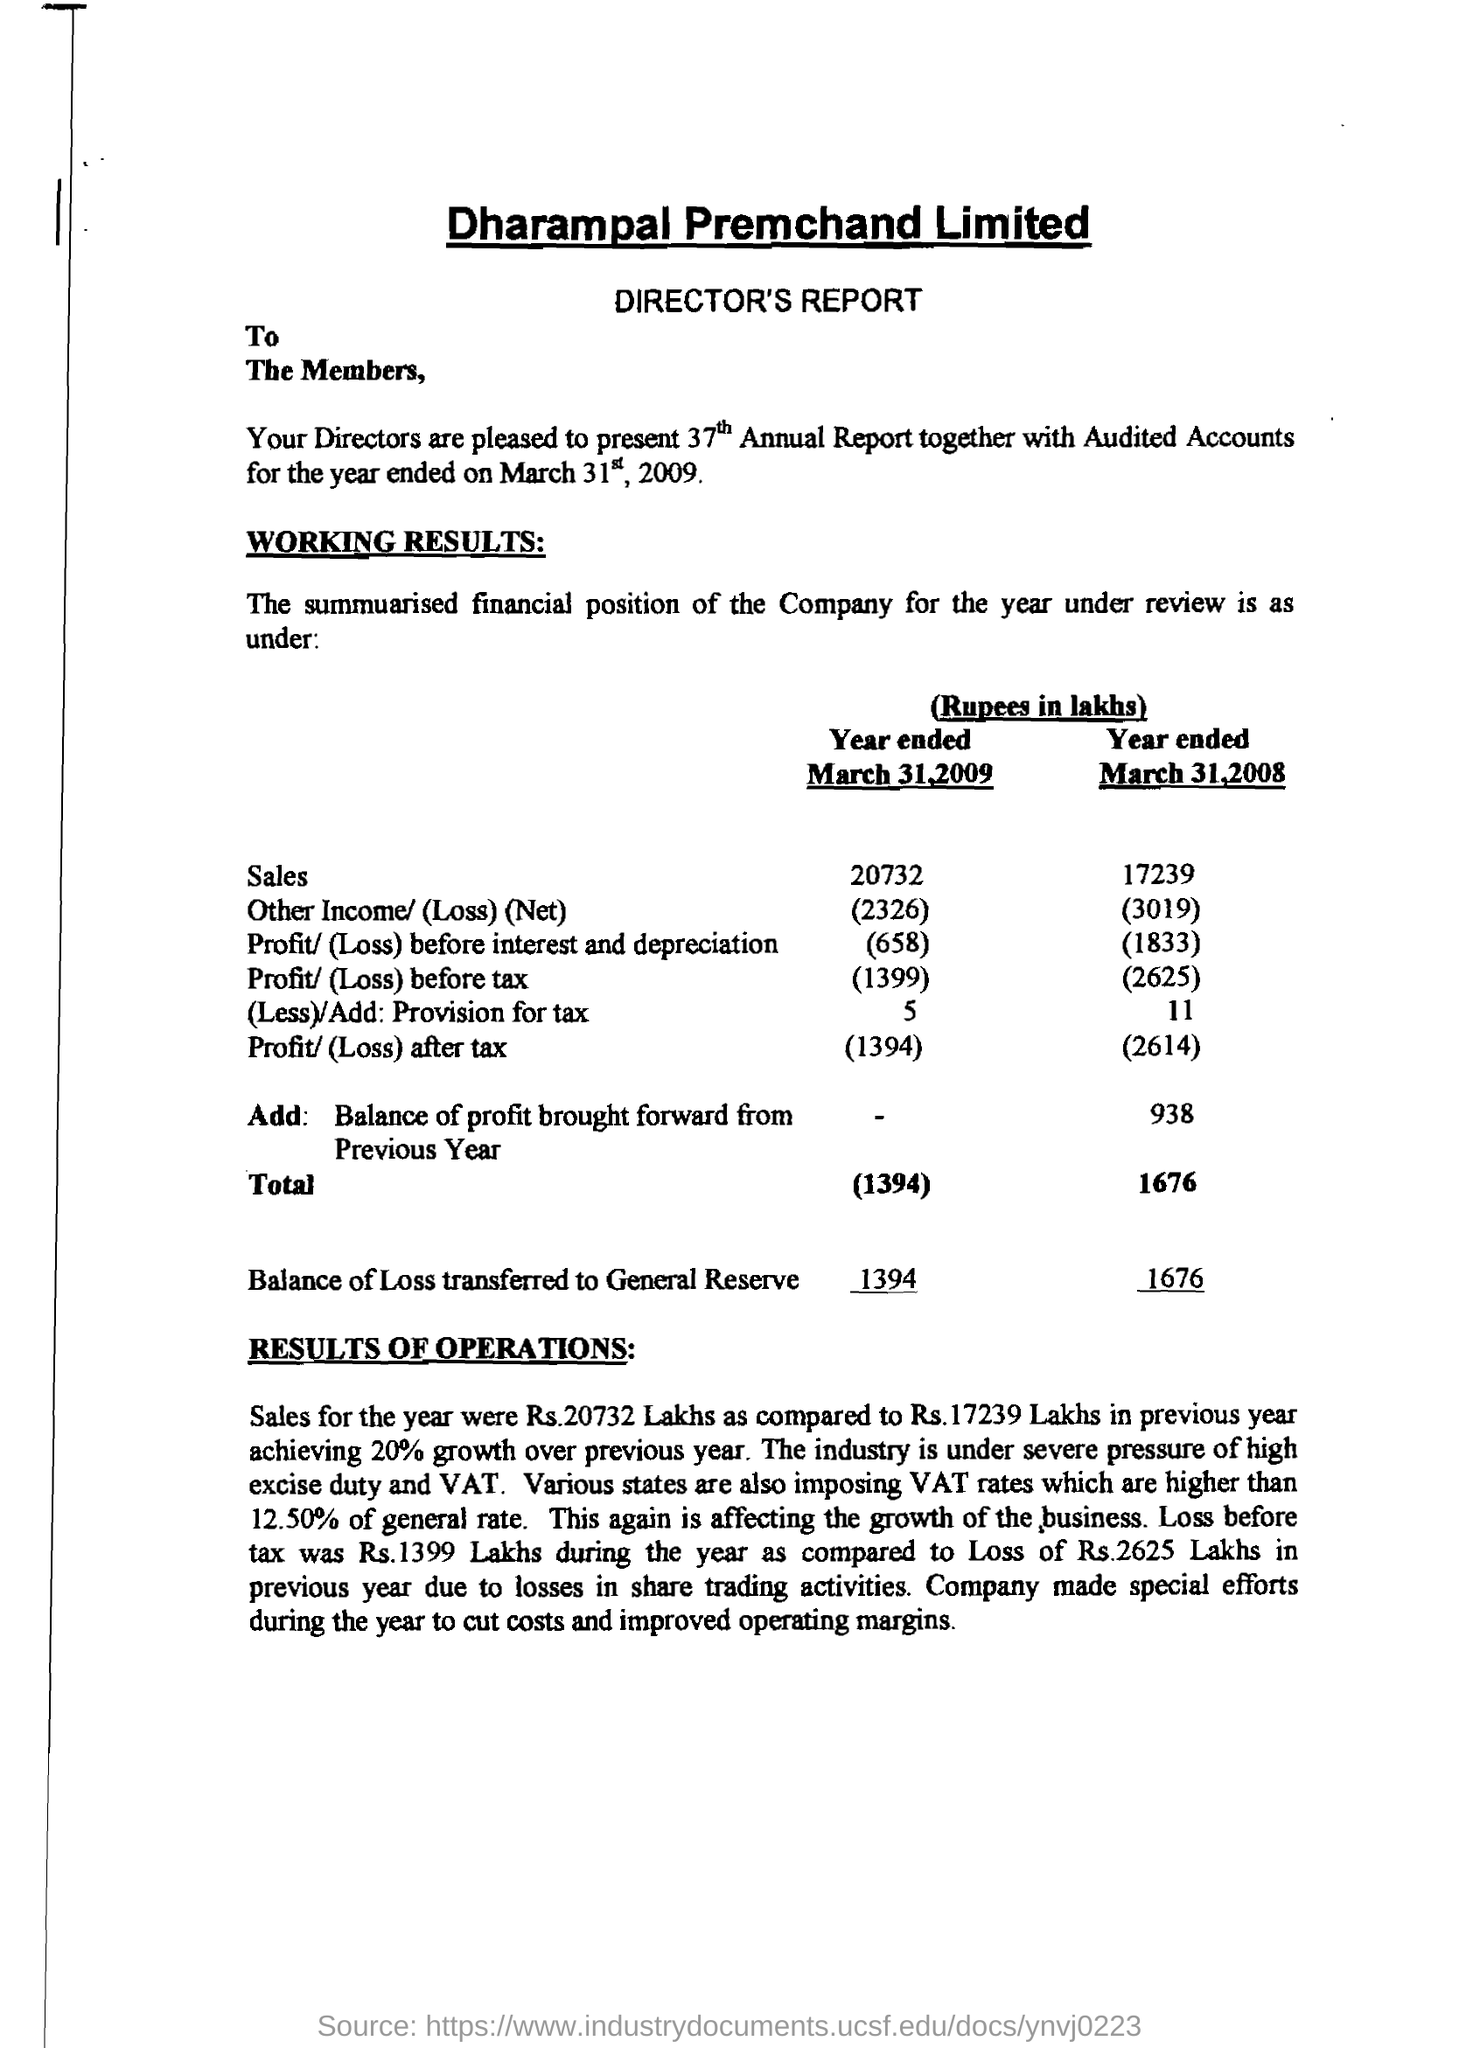Mention a couple of crucial points in this snapshot. The loss before tax for the year 2009 was 1,399. The previous year's growth was 20%, and this year's growth achieved was what percentage of that growth? The balance of loss transferred to the general reserve for the year ended March 31, 2008, was 1676 lakhs. The "loss before interest and depreciation" for the year ended on March 31, 2008 was 1833. The sales for the year ended March 31, 2009, amounted to 20732 lakhs. 